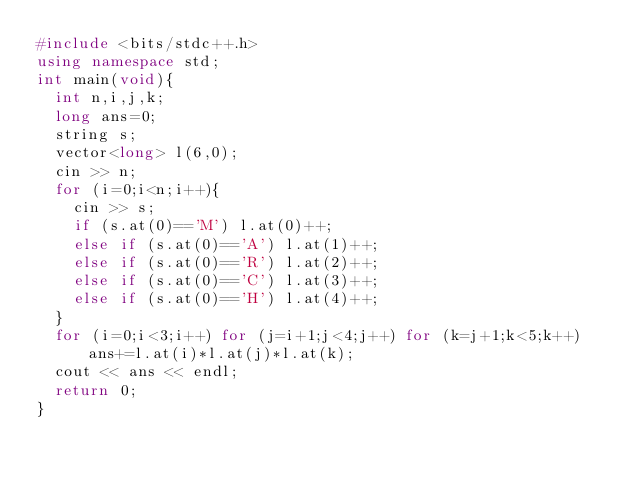<code> <loc_0><loc_0><loc_500><loc_500><_C++_>#include <bits/stdc++.h>
using namespace std;
int main(void){
  int n,i,j,k;
  long ans=0;
  string s;
  vector<long> l(6,0);
  cin >> n;
  for (i=0;i<n;i++){
    cin >> s;
    if (s.at(0)=='M') l.at(0)++;
    else if (s.at(0)=='A') l.at(1)++;
    else if (s.at(0)=='R') l.at(2)++;
    else if (s.at(0)=='C') l.at(3)++;
    else if (s.at(0)=='H') l.at(4)++;
  }
  for (i=0;i<3;i++) for (j=i+1;j<4;j++) for (k=j+1;k<5;k++) ans+=l.at(i)*l.at(j)*l.at(k);
  cout << ans << endl;
  return 0;
}</code> 